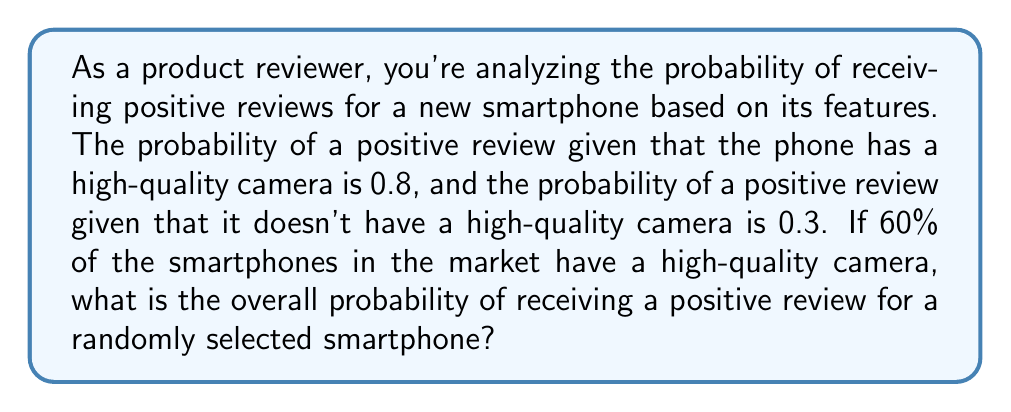Can you answer this question? Let's approach this step-by-step using the law of total probability:

1) Let's define our events:
   A = event of receiving a positive review
   B = event of the phone having a high-quality camera

2) We're given:
   $P(A|B) = 0.8$ (probability of positive review given high-quality camera)
   $P(A|B^c) = 0.3$ (probability of positive review given no high-quality camera)
   $P(B) = 0.6$ (probability of high-quality camera)

3) We can calculate $P(B^c)$:
   $P(B^c) = 1 - P(B) = 1 - 0.6 = 0.4$

4) Now, we can use the law of total probability:
   $P(A) = P(A|B) \cdot P(B) + P(A|B^c) \cdot P(B^c)$

5) Substituting our values:
   $P(A) = 0.8 \cdot 0.6 + 0.3 \cdot 0.4$

6) Calculating:
   $P(A) = 0.48 + 0.12 = 0.6$

Therefore, the overall probability of receiving a positive review for a randomly selected smartphone is 0.6 or 60%.
Answer: $0.6$ or $60\%$ 